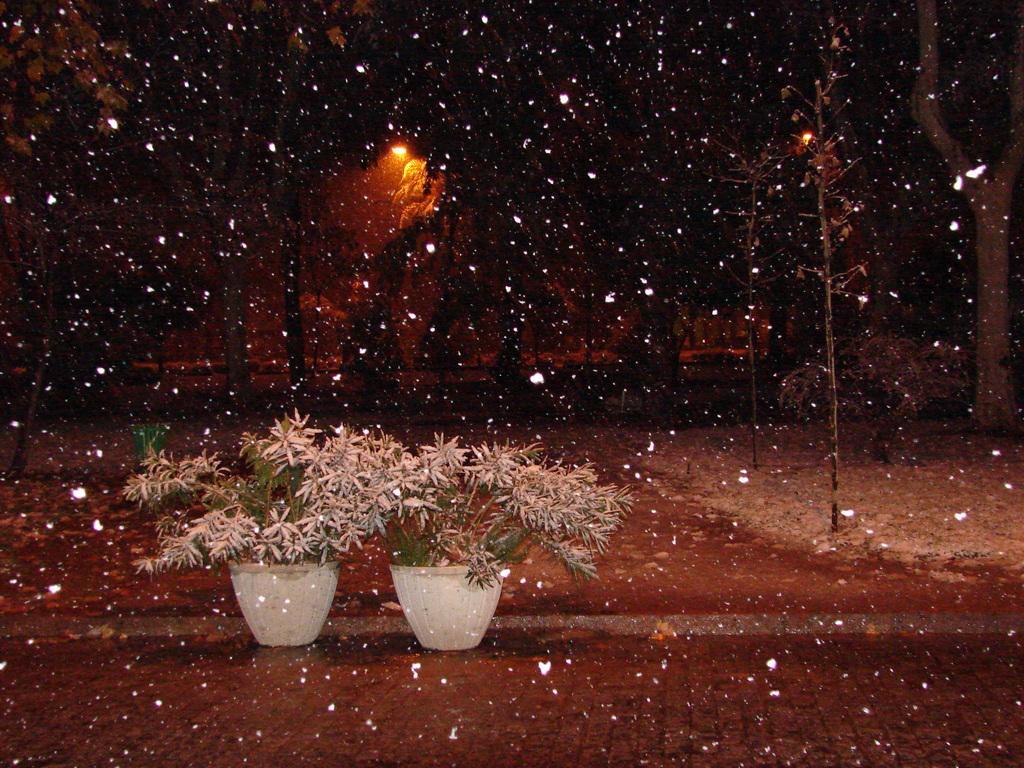In one or two sentences, can you explain what this image depicts? At the bottom of the picture there are two plants in flower pots. It is snowing in the picture. In the background there are trees, poles, snow and a street light. 